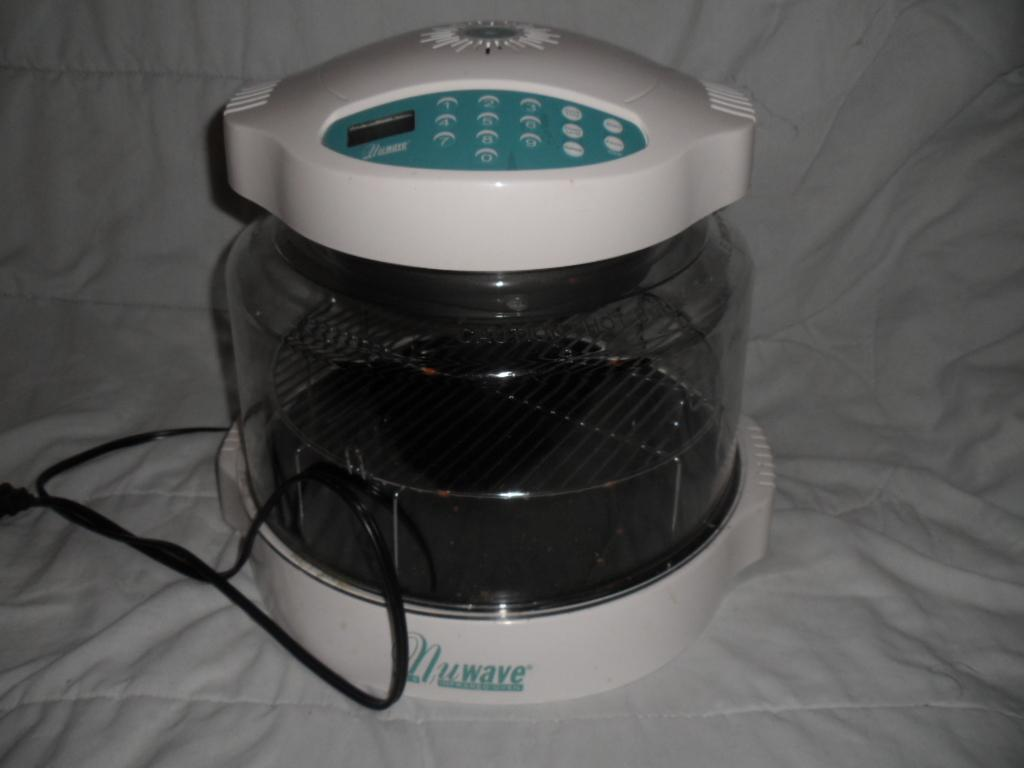<image>
Summarize the visual content of the image. An appliance with the brand Nuwave on the bottom of the product. 